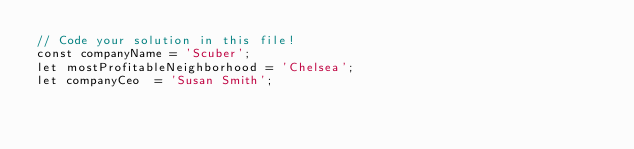<code> <loc_0><loc_0><loc_500><loc_500><_JavaScript_>// Code your solution in this file!
const companyName = 'Scuber';
let mostProfitableNeighborhood = 'Chelsea';
let companyCeo  = 'Susan Smith';</code> 